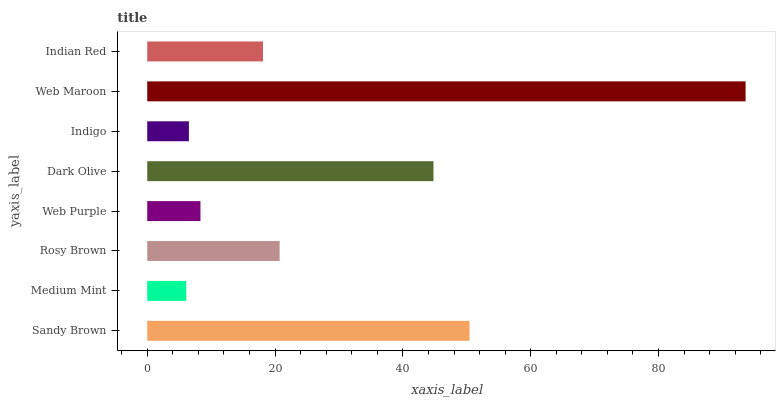Is Medium Mint the minimum?
Answer yes or no. Yes. Is Web Maroon the maximum?
Answer yes or no. Yes. Is Rosy Brown the minimum?
Answer yes or no. No. Is Rosy Brown the maximum?
Answer yes or no. No. Is Rosy Brown greater than Medium Mint?
Answer yes or no. Yes. Is Medium Mint less than Rosy Brown?
Answer yes or no. Yes. Is Medium Mint greater than Rosy Brown?
Answer yes or no. No. Is Rosy Brown less than Medium Mint?
Answer yes or no. No. Is Rosy Brown the high median?
Answer yes or no. Yes. Is Indian Red the low median?
Answer yes or no. Yes. Is Web Maroon the high median?
Answer yes or no. No. Is Dark Olive the low median?
Answer yes or no. No. 